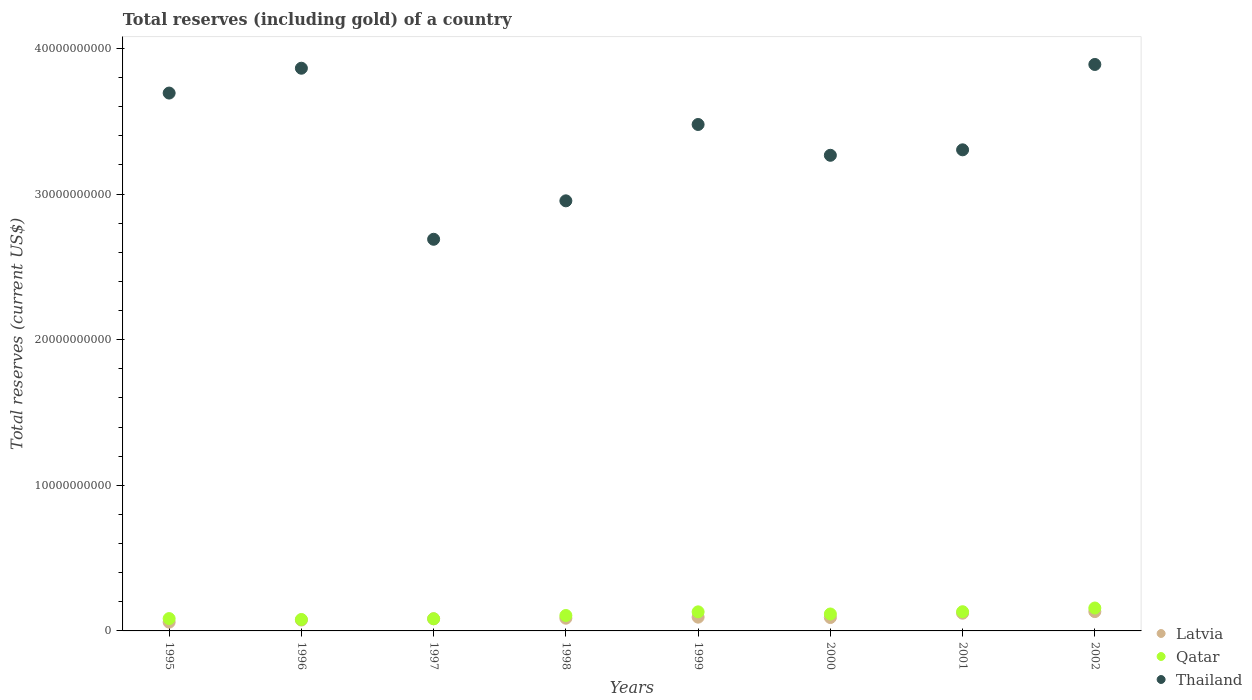How many different coloured dotlines are there?
Your answer should be very brief. 3. What is the total reserves (including gold) in Qatar in 2001?
Ensure brevity in your answer.  1.32e+09. Across all years, what is the maximum total reserves (including gold) in Qatar?
Offer a terse response. 1.57e+09. Across all years, what is the minimum total reserves (including gold) in Latvia?
Offer a terse response. 6.02e+08. In which year was the total reserves (including gold) in Latvia minimum?
Offer a terse response. 1995. What is the total total reserves (including gold) in Latvia in the graph?
Keep it short and to the point. 7.46e+09. What is the difference between the total reserves (including gold) in Latvia in 1999 and that in 2000?
Offer a terse response. 2.52e+07. What is the difference between the total reserves (including gold) in Qatar in 1997 and the total reserves (including gold) in Thailand in 1995?
Your answer should be very brief. -3.61e+1. What is the average total reserves (including gold) in Latvia per year?
Offer a very short reply. 9.33e+08. In the year 1996, what is the difference between the total reserves (including gold) in Thailand and total reserves (including gold) in Latvia?
Offer a very short reply. 3.79e+1. In how many years, is the total reserves (including gold) in Thailand greater than 14000000000 US$?
Your answer should be compact. 8. What is the ratio of the total reserves (including gold) in Qatar in 1999 to that in 2001?
Your answer should be compact. 0.99. What is the difference between the highest and the second highest total reserves (including gold) in Latvia?
Ensure brevity in your answer.  1.09e+08. What is the difference between the highest and the lowest total reserves (including gold) in Latvia?
Make the answer very short. 7.25e+08. In how many years, is the total reserves (including gold) in Latvia greater than the average total reserves (including gold) in Latvia taken over all years?
Your answer should be very brief. 3. Does the total reserves (including gold) in Thailand monotonically increase over the years?
Your answer should be compact. No. Is the total reserves (including gold) in Thailand strictly less than the total reserves (including gold) in Qatar over the years?
Your answer should be compact. No. How many dotlines are there?
Keep it short and to the point. 3. Are the values on the major ticks of Y-axis written in scientific E-notation?
Ensure brevity in your answer.  No. Does the graph contain any zero values?
Your answer should be very brief. No. Does the graph contain grids?
Your answer should be very brief. No. Where does the legend appear in the graph?
Provide a succinct answer. Bottom right. How many legend labels are there?
Your response must be concise. 3. What is the title of the graph?
Ensure brevity in your answer.  Total reserves (including gold) of a country. Does "Maldives" appear as one of the legend labels in the graph?
Offer a very short reply. No. What is the label or title of the X-axis?
Keep it short and to the point. Years. What is the label or title of the Y-axis?
Keep it short and to the point. Total reserves (current US$). What is the Total reserves (current US$) in Latvia in 1995?
Give a very brief answer. 6.02e+08. What is the Total reserves (current US$) of Qatar in 1995?
Provide a succinct answer. 8.48e+08. What is the Total reserves (current US$) of Thailand in 1995?
Provide a succinct answer. 3.69e+1. What is the Total reserves (current US$) in Latvia in 1996?
Ensure brevity in your answer.  7.46e+08. What is the Total reserves (current US$) of Qatar in 1996?
Your response must be concise. 7.85e+08. What is the Total reserves (current US$) in Thailand in 1996?
Your response must be concise. 3.86e+1. What is the Total reserves (current US$) of Latvia in 1997?
Offer a terse response. 8.32e+08. What is the Total reserves (current US$) of Qatar in 1997?
Provide a succinct answer. 8.36e+08. What is the Total reserves (current US$) of Thailand in 1997?
Make the answer very short. 2.69e+1. What is the Total reserves (current US$) in Latvia in 1998?
Provide a succinct answer. 8.73e+08. What is the Total reserves (current US$) of Qatar in 1998?
Provide a succinct answer. 1.06e+09. What is the Total reserves (current US$) of Thailand in 1998?
Your answer should be very brief. 2.95e+1. What is the Total reserves (current US$) of Latvia in 1999?
Keep it short and to the point. 9.44e+08. What is the Total reserves (current US$) of Qatar in 1999?
Your response must be concise. 1.31e+09. What is the Total reserves (current US$) in Thailand in 1999?
Give a very brief answer. 3.48e+1. What is the Total reserves (current US$) in Latvia in 2000?
Make the answer very short. 9.19e+08. What is the Total reserves (current US$) of Qatar in 2000?
Ensure brevity in your answer.  1.16e+09. What is the Total reserves (current US$) in Thailand in 2000?
Provide a succinct answer. 3.27e+1. What is the Total reserves (current US$) of Latvia in 2001?
Offer a terse response. 1.22e+09. What is the Total reserves (current US$) in Qatar in 2001?
Give a very brief answer. 1.32e+09. What is the Total reserves (current US$) in Thailand in 2001?
Your response must be concise. 3.30e+1. What is the Total reserves (current US$) of Latvia in 2002?
Provide a succinct answer. 1.33e+09. What is the Total reserves (current US$) in Qatar in 2002?
Provide a succinct answer. 1.57e+09. What is the Total reserves (current US$) of Thailand in 2002?
Provide a short and direct response. 3.89e+1. Across all years, what is the maximum Total reserves (current US$) in Latvia?
Keep it short and to the point. 1.33e+09. Across all years, what is the maximum Total reserves (current US$) of Qatar?
Keep it short and to the point. 1.57e+09. Across all years, what is the maximum Total reserves (current US$) of Thailand?
Your answer should be compact. 3.89e+1. Across all years, what is the minimum Total reserves (current US$) of Latvia?
Keep it short and to the point. 6.02e+08. Across all years, what is the minimum Total reserves (current US$) in Qatar?
Your answer should be compact. 7.85e+08. Across all years, what is the minimum Total reserves (current US$) of Thailand?
Provide a succinct answer. 2.69e+1. What is the total Total reserves (current US$) of Latvia in the graph?
Make the answer very short. 7.46e+09. What is the total Total reserves (current US$) in Qatar in the graph?
Provide a succinct answer. 8.89e+09. What is the total Total reserves (current US$) of Thailand in the graph?
Provide a short and direct response. 2.71e+11. What is the difference between the Total reserves (current US$) of Latvia in 1995 and that in 1996?
Offer a very short reply. -1.44e+08. What is the difference between the Total reserves (current US$) in Qatar in 1995 and that in 1996?
Provide a short and direct response. 6.23e+07. What is the difference between the Total reserves (current US$) in Thailand in 1995 and that in 1996?
Ensure brevity in your answer.  -1.71e+09. What is the difference between the Total reserves (current US$) of Latvia in 1995 and that in 1997?
Provide a succinct answer. -2.30e+08. What is the difference between the Total reserves (current US$) of Qatar in 1995 and that in 1997?
Offer a terse response. 1.13e+07. What is the difference between the Total reserves (current US$) in Thailand in 1995 and that in 1997?
Your response must be concise. 1.00e+1. What is the difference between the Total reserves (current US$) in Latvia in 1995 and that in 1998?
Make the answer very short. -2.71e+08. What is the difference between the Total reserves (current US$) in Qatar in 1995 and that in 1998?
Provide a succinct answer. -2.11e+08. What is the difference between the Total reserves (current US$) in Thailand in 1995 and that in 1998?
Offer a terse response. 7.40e+09. What is the difference between the Total reserves (current US$) in Latvia in 1995 and that in 1999?
Your answer should be very brief. -3.42e+08. What is the difference between the Total reserves (current US$) of Qatar in 1995 and that in 1999?
Your response must be concise. -4.62e+08. What is the difference between the Total reserves (current US$) of Thailand in 1995 and that in 1999?
Make the answer very short. 2.16e+09. What is the difference between the Total reserves (current US$) of Latvia in 1995 and that in 2000?
Your response must be concise. -3.17e+08. What is the difference between the Total reserves (current US$) of Qatar in 1995 and that in 2000?
Your answer should be very brief. -3.16e+08. What is the difference between the Total reserves (current US$) in Thailand in 1995 and that in 2000?
Offer a very short reply. 4.27e+09. What is the difference between the Total reserves (current US$) in Latvia in 1995 and that in 2001?
Your response must be concise. -6.15e+08. What is the difference between the Total reserves (current US$) in Qatar in 1995 and that in 2001?
Your response must be concise. -4.70e+08. What is the difference between the Total reserves (current US$) of Thailand in 1995 and that in 2001?
Provide a short and direct response. 3.90e+09. What is the difference between the Total reserves (current US$) of Latvia in 1995 and that in 2002?
Make the answer very short. -7.25e+08. What is the difference between the Total reserves (current US$) of Qatar in 1995 and that in 2002?
Provide a short and direct response. -7.26e+08. What is the difference between the Total reserves (current US$) in Thailand in 1995 and that in 2002?
Keep it short and to the point. -1.96e+09. What is the difference between the Total reserves (current US$) in Latvia in 1996 and that in 1997?
Your answer should be compact. -8.64e+07. What is the difference between the Total reserves (current US$) of Qatar in 1996 and that in 1997?
Your answer should be compact. -5.11e+07. What is the difference between the Total reserves (current US$) of Thailand in 1996 and that in 1997?
Keep it short and to the point. 1.17e+1. What is the difference between the Total reserves (current US$) in Latvia in 1996 and that in 1998?
Give a very brief answer. -1.27e+08. What is the difference between the Total reserves (current US$) of Qatar in 1996 and that in 1998?
Provide a succinct answer. -2.74e+08. What is the difference between the Total reserves (current US$) in Thailand in 1996 and that in 1998?
Offer a terse response. 9.11e+09. What is the difference between the Total reserves (current US$) of Latvia in 1996 and that in 1999?
Provide a short and direct response. -1.98e+08. What is the difference between the Total reserves (current US$) in Qatar in 1996 and that in 1999?
Your answer should be compact. -5.24e+08. What is the difference between the Total reserves (current US$) of Thailand in 1996 and that in 1999?
Offer a very short reply. 3.86e+09. What is the difference between the Total reserves (current US$) in Latvia in 1996 and that in 2000?
Your answer should be very brief. -1.73e+08. What is the difference between the Total reserves (current US$) of Qatar in 1996 and that in 2000?
Keep it short and to the point. -3.78e+08. What is the difference between the Total reserves (current US$) of Thailand in 1996 and that in 2000?
Offer a terse response. 5.98e+09. What is the difference between the Total reserves (current US$) in Latvia in 1996 and that in 2001?
Ensure brevity in your answer.  -4.71e+08. What is the difference between the Total reserves (current US$) in Qatar in 1996 and that in 2001?
Ensure brevity in your answer.  -5.33e+08. What is the difference between the Total reserves (current US$) of Thailand in 1996 and that in 2001?
Your answer should be very brief. 5.60e+09. What is the difference between the Total reserves (current US$) in Latvia in 1996 and that in 2002?
Ensure brevity in your answer.  -5.81e+08. What is the difference between the Total reserves (current US$) of Qatar in 1996 and that in 2002?
Make the answer very short. -7.88e+08. What is the difference between the Total reserves (current US$) in Thailand in 1996 and that in 2002?
Give a very brief answer. -2.59e+08. What is the difference between the Total reserves (current US$) in Latvia in 1997 and that in 1998?
Offer a terse response. -4.05e+07. What is the difference between the Total reserves (current US$) of Qatar in 1997 and that in 1998?
Your response must be concise. -2.23e+08. What is the difference between the Total reserves (current US$) of Thailand in 1997 and that in 1998?
Your answer should be compact. -2.64e+09. What is the difference between the Total reserves (current US$) in Latvia in 1997 and that in 1999?
Offer a very short reply. -1.12e+08. What is the difference between the Total reserves (current US$) of Qatar in 1997 and that in 1999?
Keep it short and to the point. -4.73e+08. What is the difference between the Total reserves (current US$) in Thailand in 1997 and that in 1999?
Offer a terse response. -7.88e+09. What is the difference between the Total reserves (current US$) in Latvia in 1997 and that in 2000?
Offer a terse response. -8.67e+07. What is the difference between the Total reserves (current US$) in Qatar in 1997 and that in 2000?
Provide a short and direct response. -3.27e+08. What is the difference between the Total reserves (current US$) of Thailand in 1997 and that in 2000?
Keep it short and to the point. -5.77e+09. What is the difference between the Total reserves (current US$) of Latvia in 1997 and that in 2001?
Make the answer very short. -3.85e+08. What is the difference between the Total reserves (current US$) in Qatar in 1997 and that in 2001?
Make the answer very short. -4.82e+08. What is the difference between the Total reserves (current US$) of Thailand in 1997 and that in 2001?
Offer a very short reply. -6.14e+09. What is the difference between the Total reserves (current US$) of Latvia in 1997 and that in 2002?
Your answer should be very brief. -4.94e+08. What is the difference between the Total reserves (current US$) in Qatar in 1997 and that in 2002?
Keep it short and to the point. -7.37e+08. What is the difference between the Total reserves (current US$) of Thailand in 1997 and that in 2002?
Offer a terse response. -1.20e+1. What is the difference between the Total reserves (current US$) of Latvia in 1998 and that in 1999?
Give a very brief answer. -7.14e+07. What is the difference between the Total reserves (current US$) in Qatar in 1998 and that in 1999?
Your answer should be compact. -2.51e+08. What is the difference between the Total reserves (current US$) in Thailand in 1998 and that in 1999?
Your answer should be compact. -5.24e+09. What is the difference between the Total reserves (current US$) of Latvia in 1998 and that in 2000?
Ensure brevity in your answer.  -4.62e+07. What is the difference between the Total reserves (current US$) of Qatar in 1998 and that in 2000?
Keep it short and to the point. -1.04e+08. What is the difference between the Total reserves (current US$) of Thailand in 1998 and that in 2000?
Make the answer very short. -3.13e+09. What is the difference between the Total reserves (current US$) in Latvia in 1998 and that in 2001?
Your response must be concise. -3.45e+08. What is the difference between the Total reserves (current US$) in Qatar in 1998 and that in 2001?
Keep it short and to the point. -2.59e+08. What is the difference between the Total reserves (current US$) of Thailand in 1998 and that in 2001?
Ensure brevity in your answer.  -3.50e+09. What is the difference between the Total reserves (current US$) of Latvia in 1998 and that in 2002?
Make the answer very short. -4.54e+08. What is the difference between the Total reserves (current US$) of Qatar in 1998 and that in 2002?
Provide a short and direct response. -5.14e+08. What is the difference between the Total reserves (current US$) of Thailand in 1998 and that in 2002?
Your answer should be compact. -9.37e+09. What is the difference between the Total reserves (current US$) in Latvia in 1999 and that in 2000?
Make the answer very short. 2.52e+07. What is the difference between the Total reserves (current US$) of Qatar in 1999 and that in 2000?
Give a very brief answer. 1.47e+08. What is the difference between the Total reserves (current US$) in Thailand in 1999 and that in 2000?
Offer a very short reply. 2.12e+09. What is the difference between the Total reserves (current US$) of Latvia in 1999 and that in 2001?
Give a very brief answer. -2.73e+08. What is the difference between the Total reserves (current US$) of Qatar in 1999 and that in 2001?
Your response must be concise. -8.23e+06. What is the difference between the Total reserves (current US$) in Thailand in 1999 and that in 2001?
Ensure brevity in your answer.  1.74e+09. What is the difference between the Total reserves (current US$) of Latvia in 1999 and that in 2002?
Make the answer very short. -3.82e+08. What is the difference between the Total reserves (current US$) of Qatar in 1999 and that in 2002?
Make the answer very short. -2.64e+08. What is the difference between the Total reserves (current US$) of Thailand in 1999 and that in 2002?
Ensure brevity in your answer.  -4.12e+09. What is the difference between the Total reserves (current US$) in Latvia in 2000 and that in 2001?
Offer a terse response. -2.98e+08. What is the difference between the Total reserves (current US$) of Qatar in 2000 and that in 2001?
Give a very brief answer. -1.55e+08. What is the difference between the Total reserves (current US$) in Thailand in 2000 and that in 2001?
Your answer should be very brief. -3.75e+08. What is the difference between the Total reserves (current US$) of Latvia in 2000 and that in 2002?
Your answer should be very brief. -4.07e+08. What is the difference between the Total reserves (current US$) of Qatar in 2000 and that in 2002?
Your answer should be compact. -4.10e+08. What is the difference between the Total reserves (current US$) in Thailand in 2000 and that in 2002?
Make the answer very short. -6.24e+09. What is the difference between the Total reserves (current US$) in Latvia in 2001 and that in 2002?
Your answer should be compact. -1.09e+08. What is the difference between the Total reserves (current US$) in Qatar in 2001 and that in 2002?
Keep it short and to the point. -2.55e+08. What is the difference between the Total reserves (current US$) in Thailand in 2001 and that in 2002?
Your response must be concise. -5.86e+09. What is the difference between the Total reserves (current US$) in Latvia in 1995 and the Total reserves (current US$) in Qatar in 1996?
Provide a succinct answer. -1.83e+08. What is the difference between the Total reserves (current US$) of Latvia in 1995 and the Total reserves (current US$) of Thailand in 1996?
Your answer should be very brief. -3.80e+1. What is the difference between the Total reserves (current US$) in Qatar in 1995 and the Total reserves (current US$) in Thailand in 1996?
Give a very brief answer. -3.78e+1. What is the difference between the Total reserves (current US$) in Latvia in 1995 and the Total reserves (current US$) in Qatar in 1997?
Provide a short and direct response. -2.34e+08. What is the difference between the Total reserves (current US$) in Latvia in 1995 and the Total reserves (current US$) in Thailand in 1997?
Make the answer very short. -2.63e+1. What is the difference between the Total reserves (current US$) of Qatar in 1995 and the Total reserves (current US$) of Thailand in 1997?
Offer a very short reply. -2.60e+1. What is the difference between the Total reserves (current US$) of Latvia in 1995 and the Total reserves (current US$) of Qatar in 1998?
Your response must be concise. -4.57e+08. What is the difference between the Total reserves (current US$) in Latvia in 1995 and the Total reserves (current US$) in Thailand in 1998?
Provide a short and direct response. -2.89e+1. What is the difference between the Total reserves (current US$) of Qatar in 1995 and the Total reserves (current US$) of Thailand in 1998?
Provide a short and direct response. -2.87e+1. What is the difference between the Total reserves (current US$) in Latvia in 1995 and the Total reserves (current US$) in Qatar in 1999?
Provide a succinct answer. -7.08e+08. What is the difference between the Total reserves (current US$) in Latvia in 1995 and the Total reserves (current US$) in Thailand in 1999?
Provide a succinct answer. -3.42e+1. What is the difference between the Total reserves (current US$) in Qatar in 1995 and the Total reserves (current US$) in Thailand in 1999?
Give a very brief answer. -3.39e+1. What is the difference between the Total reserves (current US$) of Latvia in 1995 and the Total reserves (current US$) of Qatar in 2000?
Offer a very short reply. -5.61e+08. What is the difference between the Total reserves (current US$) of Latvia in 1995 and the Total reserves (current US$) of Thailand in 2000?
Offer a terse response. -3.21e+1. What is the difference between the Total reserves (current US$) in Qatar in 1995 and the Total reserves (current US$) in Thailand in 2000?
Give a very brief answer. -3.18e+1. What is the difference between the Total reserves (current US$) of Latvia in 1995 and the Total reserves (current US$) of Qatar in 2001?
Provide a succinct answer. -7.16e+08. What is the difference between the Total reserves (current US$) of Latvia in 1995 and the Total reserves (current US$) of Thailand in 2001?
Your answer should be compact. -3.24e+1. What is the difference between the Total reserves (current US$) of Qatar in 1995 and the Total reserves (current US$) of Thailand in 2001?
Provide a short and direct response. -3.22e+1. What is the difference between the Total reserves (current US$) in Latvia in 1995 and the Total reserves (current US$) in Qatar in 2002?
Provide a succinct answer. -9.71e+08. What is the difference between the Total reserves (current US$) in Latvia in 1995 and the Total reserves (current US$) in Thailand in 2002?
Your response must be concise. -3.83e+1. What is the difference between the Total reserves (current US$) of Qatar in 1995 and the Total reserves (current US$) of Thailand in 2002?
Your response must be concise. -3.81e+1. What is the difference between the Total reserves (current US$) in Latvia in 1996 and the Total reserves (current US$) in Qatar in 1997?
Your answer should be very brief. -9.02e+07. What is the difference between the Total reserves (current US$) in Latvia in 1996 and the Total reserves (current US$) in Thailand in 1997?
Ensure brevity in your answer.  -2.62e+1. What is the difference between the Total reserves (current US$) in Qatar in 1996 and the Total reserves (current US$) in Thailand in 1997?
Your response must be concise. -2.61e+1. What is the difference between the Total reserves (current US$) in Latvia in 1996 and the Total reserves (current US$) in Qatar in 1998?
Your answer should be very brief. -3.13e+08. What is the difference between the Total reserves (current US$) of Latvia in 1996 and the Total reserves (current US$) of Thailand in 1998?
Provide a succinct answer. -2.88e+1. What is the difference between the Total reserves (current US$) in Qatar in 1996 and the Total reserves (current US$) in Thailand in 1998?
Keep it short and to the point. -2.88e+1. What is the difference between the Total reserves (current US$) in Latvia in 1996 and the Total reserves (current US$) in Qatar in 1999?
Ensure brevity in your answer.  -5.64e+08. What is the difference between the Total reserves (current US$) of Latvia in 1996 and the Total reserves (current US$) of Thailand in 1999?
Give a very brief answer. -3.40e+1. What is the difference between the Total reserves (current US$) in Qatar in 1996 and the Total reserves (current US$) in Thailand in 1999?
Offer a very short reply. -3.40e+1. What is the difference between the Total reserves (current US$) in Latvia in 1996 and the Total reserves (current US$) in Qatar in 2000?
Offer a terse response. -4.17e+08. What is the difference between the Total reserves (current US$) in Latvia in 1996 and the Total reserves (current US$) in Thailand in 2000?
Your answer should be very brief. -3.19e+1. What is the difference between the Total reserves (current US$) of Qatar in 1996 and the Total reserves (current US$) of Thailand in 2000?
Make the answer very short. -3.19e+1. What is the difference between the Total reserves (current US$) of Latvia in 1996 and the Total reserves (current US$) of Qatar in 2001?
Offer a terse response. -5.72e+08. What is the difference between the Total reserves (current US$) of Latvia in 1996 and the Total reserves (current US$) of Thailand in 2001?
Make the answer very short. -3.23e+1. What is the difference between the Total reserves (current US$) of Qatar in 1996 and the Total reserves (current US$) of Thailand in 2001?
Offer a very short reply. -3.23e+1. What is the difference between the Total reserves (current US$) in Latvia in 1996 and the Total reserves (current US$) in Qatar in 2002?
Provide a succinct answer. -8.27e+08. What is the difference between the Total reserves (current US$) of Latvia in 1996 and the Total reserves (current US$) of Thailand in 2002?
Provide a succinct answer. -3.82e+1. What is the difference between the Total reserves (current US$) in Qatar in 1996 and the Total reserves (current US$) in Thailand in 2002?
Your response must be concise. -3.81e+1. What is the difference between the Total reserves (current US$) of Latvia in 1997 and the Total reserves (current US$) of Qatar in 1998?
Provide a short and direct response. -2.26e+08. What is the difference between the Total reserves (current US$) of Latvia in 1997 and the Total reserves (current US$) of Thailand in 1998?
Offer a very short reply. -2.87e+1. What is the difference between the Total reserves (current US$) of Qatar in 1997 and the Total reserves (current US$) of Thailand in 1998?
Offer a very short reply. -2.87e+1. What is the difference between the Total reserves (current US$) of Latvia in 1997 and the Total reserves (current US$) of Qatar in 1999?
Provide a short and direct response. -4.77e+08. What is the difference between the Total reserves (current US$) in Latvia in 1997 and the Total reserves (current US$) in Thailand in 1999?
Ensure brevity in your answer.  -3.39e+1. What is the difference between the Total reserves (current US$) in Qatar in 1997 and the Total reserves (current US$) in Thailand in 1999?
Provide a succinct answer. -3.39e+1. What is the difference between the Total reserves (current US$) in Latvia in 1997 and the Total reserves (current US$) in Qatar in 2000?
Your response must be concise. -3.31e+08. What is the difference between the Total reserves (current US$) of Latvia in 1997 and the Total reserves (current US$) of Thailand in 2000?
Provide a succinct answer. -3.18e+1. What is the difference between the Total reserves (current US$) in Qatar in 1997 and the Total reserves (current US$) in Thailand in 2000?
Your answer should be very brief. -3.18e+1. What is the difference between the Total reserves (current US$) of Latvia in 1997 and the Total reserves (current US$) of Qatar in 2001?
Give a very brief answer. -4.85e+08. What is the difference between the Total reserves (current US$) of Latvia in 1997 and the Total reserves (current US$) of Thailand in 2001?
Provide a short and direct response. -3.22e+1. What is the difference between the Total reserves (current US$) of Qatar in 1997 and the Total reserves (current US$) of Thailand in 2001?
Your answer should be compact. -3.22e+1. What is the difference between the Total reserves (current US$) of Latvia in 1997 and the Total reserves (current US$) of Qatar in 2002?
Provide a short and direct response. -7.41e+08. What is the difference between the Total reserves (current US$) of Latvia in 1997 and the Total reserves (current US$) of Thailand in 2002?
Offer a terse response. -3.81e+1. What is the difference between the Total reserves (current US$) in Qatar in 1997 and the Total reserves (current US$) in Thailand in 2002?
Offer a very short reply. -3.81e+1. What is the difference between the Total reserves (current US$) of Latvia in 1998 and the Total reserves (current US$) of Qatar in 1999?
Give a very brief answer. -4.37e+08. What is the difference between the Total reserves (current US$) in Latvia in 1998 and the Total reserves (current US$) in Thailand in 1999?
Your response must be concise. -3.39e+1. What is the difference between the Total reserves (current US$) of Qatar in 1998 and the Total reserves (current US$) of Thailand in 1999?
Provide a succinct answer. -3.37e+1. What is the difference between the Total reserves (current US$) of Latvia in 1998 and the Total reserves (current US$) of Qatar in 2000?
Give a very brief answer. -2.90e+08. What is the difference between the Total reserves (current US$) in Latvia in 1998 and the Total reserves (current US$) in Thailand in 2000?
Provide a short and direct response. -3.18e+1. What is the difference between the Total reserves (current US$) of Qatar in 1998 and the Total reserves (current US$) of Thailand in 2000?
Offer a terse response. -3.16e+1. What is the difference between the Total reserves (current US$) in Latvia in 1998 and the Total reserves (current US$) in Qatar in 2001?
Your response must be concise. -4.45e+08. What is the difference between the Total reserves (current US$) of Latvia in 1998 and the Total reserves (current US$) of Thailand in 2001?
Offer a very short reply. -3.22e+1. What is the difference between the Total reserves (current US$) in Qatar in 1998 and the Total reserves (current US$) in Thailand in 2001?
Provide a short and direct response. -3.20e+1. What is the difference between the Total reserves (current US$) in Latvia in 1998 and the Total reserves (current US$) in Qatar in 2002?
Ensure brevity in your answer.  -7.00e+08. What is the difference between the Total reserves (current US$) of Latvia in 1998 and the Total reserves (current US$) of Thailand in 2002?
Provide a short and direct response. -3.80e+1. What is the difference between the Total reserves (current US$) in Qatar in 1998 and the Total reserves (current US$) in Thailand in 2002?
Your answer should be compact. -3.78e+1. What is the difference between the Total reserves (current US$) in Latvia in 1999 and the Total reserves (current US$) in Qatar in 2000?
Ensure brevity in your answer.  -2.19e+08. What is the difference between the Total reserves (current US$) in Latvia in 1999 and the Total reserves (current US$) in Thailand in 2000?
Offer a terse response. -3.17e+1. What is the difference between the Total reserves (current US$) of Qatar in 1999 and the Total reserves (current US$) of Thailand in 2000?
Offer a very short reply. -3.14e+1. What is the difference between the Total reserves (current US$) in Latvia in 1999 and the Total reserves (current US$) in Qatar in 2001?
Give a very brief answer. -3.74e+08. What is the difference between the Total reserves (current US$) in Latvia in 1999 and the Total reserves (current US$) in Thailand in 2001?
Offer a terse response. -3.21e+1. What is the difference between the Total reserves (current US$) of Qatar in 1999 and the Total reserves (current US$) of Thailand in 2001?
Provide a succinct answer. -3.17e+1. What is the difference between the Total reserves (current US$) of Latvia in 1999 and the Total reserves (current US$) of Qatar in 2002?
Make the answer very short. -6.29e+08. What is the difference between the Total reserves (current US$) in Latvia in 1999 and the Total reserves (current US$) in Thailand in 2002?
Make the answer very short. -3.80e+1. What is the difference between the Total reserves (current US$) in Qatar in 1999 and the Total reserves (current US$) in Thailand in 2002?
Make the answer very short. -3.76e+1. What is the difference between the Total reserves (current US$) of Latvia in 2000 and the Total reserves (current US$) of Qatar in 2001?
Give a very brief answer. -3.99e+08. What is the difference between the Total reserves (current US$) of Latvia in 2000 and the Total reserves (current US$) of Thailand in 2001?
Offer a terse response. -3.21e+1. What is the difference between the Total reserves (current US$) of Qatar in 2000 and the Total reserves (current US$) of Thailand in 2001?
Ensure brevity in your answer.  -3.19e+1. What is the difference between the Total reserves (current US$) in Latvia in 2000 and the Total reserves (current US$) in Qatar in 2002?
Your response must be concise. -6.54e+08. What is the difference between the Total reserves (current US$) in Latvia in 2000 and the Total reserves (current US$) in Thailand in 2002?
Make the answer very short. -3.80e+1. What is the difference between the Total reserves (current US$) in Qatar in 2000 and the Total reserves (current US$) in Thailand in 2002?
Give a very brief answer. -3.77e+1. What is the difference between the Total reserves (current US$) of Latvia in 2001 and the Total reserves (current US$) of Qatar in 2002?
Your answer should be compact. -3.56e+08. What is the difference between the Total reserves (current US$) of Latvia in 2001 and the Total reserves (current US$) of Thailand in 2002?
Your response must be concise. -3.77e+1. What is the difference between the Total reserves (current US$) in Qatar in 2001 and the Total reserves (current US$) in Thailand in 2002?
Offer a terse response. -3.76e+1. What is the average Total reserves (current US$) of Latvia per year?
Keep it short and to the point. 9.33e+08. What is the average Total reserves (current US$) in Qatar per year?
Your response must be concise. 1.11e+09. What is the average Total reserves (current US$) in Thailand per year?
Offer a terse response. 3.39e+1. In the year 1995, what is the difference between the Total reserves (current US$) in Latvia and Total reserves (current US$) in Qatar?
Keep it short and to the point. -2.46e+08. In the year 1995, what is the difference between the Total reserves (current US$) of Latvia and Total reserves (current US$) of Thailand?
Ensure brevity in your answer.  -3.63e+1. In the year 1995, what is the difference between the Total reserves (current US$) of Qatar and Total reserves (current US$) of Thailand?
Give a very brief answer. -3.61e+1. In the year 1996, what is the difference between the Total reserves (current US$) in Latvia and Total reserves (current US$) in Qatar?
Make the answer very short. -3.92e+07. In the year 1996, what is the difference between the Total reserves (current US$) of Latvia and Total reserves (current US$) of Thailand?
Provide a succinct answer. -3.79e+1. In the year 1996, what is the difference between the Total reserves (current US$) in Qatar and Total reserves (current US$) in Thailand?
Your response must be concise. -3.79e+1. In the year 1997, what is the difference between the Total reserves (current US$) in Latvia and Total reserves (current US$) in Qatar?
Give a very brief answer. -3.85e+06. In the year 1997, what is the difference between the Total reserves (current US$) in Latvia and Total reserves (current US$) in Thailand?
Provide a succinct answer. -2.61e+1. In the year 1997, what is the difference between the Total reserves (current US$) of Qatar and Total reserves (current US$) of Thailand?
Your answer should be compact. -2.61e+1. In the year 1998, what is the difference between the Total reserves (current US$) of Latvia and Total reserves (current US$) of Qatar?
Your response must be concise. -1.86e+08. In the year 1998, what is the difference between the Total reserves (current US$) in Latvia and Total reserves (current US$) in Thailand?
Your response must be concise. -2.87e+1. In the year 1998, what is the difference between the Total reserves (current US$) in Qatar and Total reserves (current US$) in Thailand?
Ensure brevity in your answer.  -2.85e+1. In the year 1999, what is the difference between the Total reserves (current US$) in Latvia and Total reserves (current US$) in Qatar?
Your answer should be very brief. -3.65e+08. In the year 1999, what is the difference between the Total reserves (current US$) in Latvia and Total reserves (current US$) in Thailand?
Provide a short and direct response. -3.38e+1. In the year 1999, what is the difference between the Total reserves (current US$) in Qatar and Total reserves (current US$) in Thailand?
Make the answer very short. -3.35e+1. In the year 2000, what is the difference between the Total reserves (current US$) in Latvia and Total reserves (current US$) in Qatar?
Your response must be concise. -2.44e+08. In the year 2000, what is the difference between the Total reserves (current US$) of Latvia and Total reserves (current US$) of Thailand?
Your response must be concise. -3.17e+1. In the year 2000, what is the difference between the Total reserves (current US$) in Qatar and Total reserves (current US$) in Thailand?
Provide a succinct answer. -3.15e+1. In the year 2001, what is the difference between the Total reserves (current US$) of Latvia and Total reserves (current US$) of Qatar?
Keep it short and to the point. -1.00e+08. In the year 2001, what is the difference between the Total reserves (current US$) of Latvia and Total reserves (current US$) of Thailand?
Provide a succinct answer. -3.18e+1. In the year 2001, what is the difference between the Total reserves (current US$) of Qatar and Total reserves (current US$) of Thailand?
Make the answer very short. -3.17e+1. In the year 2002, what is the difference between the Total reserves (current US$) in Latvia and Total reserves (current US$) in Qatar?
Provide a short and direct response. -2.47e+08. In the year 2002, what is the difference between the Total reserves (current US$) of Latvia and Total reserves (current US$) of Thailand?
Offer a terse response. -3.76e+1. In the year 2002, what is the difference between the Total reserves (current US$) in Qatar and Total reserves (current US$) in Thailand?
Keep it short and to the point. -3.73e+1. What is the ratio of the Total reserves (current US$) in Latvia in 1995 to that in 1996?
Your answer should be very brief. 0.81. What is the ratio of the Total reserves (current US$) in Qatar in 1995 to that in 1996?
Make the answer very short. 1.08. What is the ratio of the Total reserves (current US$) of Thailand in 1995 to that in 1996?
Your answer should be very brief. 0.96. What is the ratio of the Total reserves (current US$) in Latvia in 1995 to that in 1997?
Give a very brief answer. 0.72. What is the ratio of the Total reserves (current US$) in Qatar in 1995 to that in 1997?
Your answer should be compact. 1.01. What is the ratio of the Total reserves (current US$) in Thailand in 1995 to that in 1997?
Your answer should be very brief. 1.37. What is the ratio of the Total reserves (current US$) in Latvia in 1995 to that in 1998?
Your response must be concise. 0.69. What is the ratio of the Total reserves (current US$) in Qatar in 1995 to that in 1998?
Offer a terse response. 0.8. What is the ratio of the Total reserves (current US$) in Thailand in 1995 to that in 1998?
Provide a short and direct response. 1.25. What is the ratio of the Total reserves (current US$) of Latvia in 1995 to that in 1999?
Offer a terse response. 0.64. What is the ratio of the Total reserves (current US$) in Qatar in 1995 to that in 1999?
Offer a very short reply. 0.65. What is the ratio of the Total reserves (current US$) of Thailand in 1995 to that in 1999?
Provide a short and direct response. 1.06. What is the ratio of the Total reserves (current US$) in Latvia in 1995 to that in 2000?
Make the answer very short. 0.66. What is the ratio of the Total reserves (current US$) of Qatar in 1995 to that in 2000?
Provide a short and direct response. 0.73. What is the ratio of the Total reserves (current US$) of Thailand in 1995 to that in 2000?
Provide a short and direct response. 1.13. What is the ratio of the Total reserves (current US$) in Latvia in 1995 to that in 2001?
Provide a short and direct response. 0.49. What is the ratio of the Total reserves (current US$) of Qatar in 1995 to that in 2001?
Provide a succinct answer. 0.64. What is the ratio of the Total reserves (current US$) of Thailand in 1995 to that in 2001?
Ensure brevity in your answer.  1.12. What is the ratio of the Total reserves (current US$) in Latvia in 1995 to that in 2002?
Your answer should be compact. 0.45. What is the ratio of the Total reserves (current US$) of Qatar in 1995 to that in 2002?
Give a very brief answer. 0.54. What is the ratio of the Total reserves (current US$) in Thailand in 1995 to that in 2002?
Give a very brief answer. 0.95. What is the ratio of the Total reserves (current US$) of Latvia in 1996 to that in 1997?
Keep it short and to the point. 0.9. What is the ratio of the Total reserves (current US$) in Qatar in 1996 to that in 1997?
Ensure brevity in your answer.  0.94. What is the ratio of the Total reserves (current US$) in Thailand in 1996 to that in 1997?
Offer a very short reply. 1.44. What is the ratio of the Total reserves (current US$) of Latvia in 1996 to that in 1998?
Ensure brevity in your answer.  0.85. What is the ratio of the Total reserves (current US$) in Qatar in 1996 to that in 1998?
Offer a very short reply. 0.74. What is the ratio of the Total reserves (current US$) of Thailand in 1996 to that in 1998?
Your answer should be compact. 1.31. What is the ratio of the Total reserves (current US$) of Latvia in 1996 to that in 1999?
Offer a terse response. 0.79. What is the ratio of the Total reserves (current US$) in Qatar in 1996 to that in 1999?
Your response must be concise. 0.6. What is the ratio of the Total reserves (current US$) in Thailand in 1996 to that in 1999?
Give a very brief answer. 1.11. What is the ratio of the Total reserves (current US$) in Latvia in 1996 to that in 2000?
Make the answer very short. 0.81. What is the ratio of the Total reserves (current US$) in Qatar in 1996 to that in 2000?
Your response must be concise. 0.68. What is the ratio of the Total reserves (current US$) of Thailand in 1996 to that in 2000?
Your answer should be very brief. 1.18. What is the ratio of the Total reserves (current US$) of Latvia in 1996 to that in 2001?
Ensure brevity in your answer.  0.61. What is the ratio of the Total reserves (current US$) of Qatar in 1996 to that in 2001?
Offer a terse response. 0.6. What is the ratio of the Total reserves (current US$) of Thailand in 1996 to that in 2001?
Provide a succinct answer. 1.17. What is the ratio of the Total reserves (current US$) of Latvia in 1996 to that in 2002?
Give a very brief answer. 0.56. What is the ratio of the Total reserves (current US$) of Qatar in 1996 to that in 2002?
Make the answer very short. 0.5. What is the ratio of the Total reserves (current US$) of Latvia in 1997 to that in 1998?
Provide a succinct answer. 0.95. What is the ratio of the Total reserves (current US$) in Qatar in 1997 to that in 1998?
Provide a succinct answer. 0.79. What is the ratio of the Total reserves (current US$) of Thailand in 1997 to that in 1998?
Make the answer very short. 0.91. What is the ratio of the Total reserves (current US$) of Latvia in 1997 to that in 1999?
Give a very brief answer. 0.88. What is the ratio of the Total reserves (current US$) in Qatar in 1997 to that in 1999?
Offer a terse response. 0.64. What is the ratio of the Total reserves (current US$) in Thailand in 1997 to that in 1999?
Keep it short and to the point. 0.77. What is the ratio of the Total reserves (current US$) in Latvia in 1997 to that in 2000?
Provide a succinct answer. 0.91. What is the ratio of the Total reserves (current US$) in Qatar in 1997 to that in 2000?
Ensure brevity in your answer.  0.72. What is the ratio of the Total reserves (current US$) of Thailand in 1997 to that in 2000?
Offer a terse response. 0.82. What is the ratio of the Total reserves (current US$) of Latvia in 1997 to that in 2001?
Offer a very short reply. 0.68. What is the ratio of the Total reserves (current US$) in Qatar in 1997 to that in 2001?
Your response must be concise. 0.63. What is the ratio of the Total reserves (current US$) of Thailand in 1997 to that in 2001?
Give a very brief answer. 0.81. What is the ratio of the Total reserves (current US$) of Latvia in 1997 to that in 2002?
Make the answer very short. 0.63. What is the ratio of the Total reserves (current US$) of Qatar in 1997 to that in 2002?
Your answer should be compact. 0.53. What is the ratio of the Total reserves (current US$) in Thailand in 1997 to that in 2002?
Give a very brief answer. 0.69. What is the ratio of the Total reserves (current US$) in Latvia in 1998 to that in 1999?
Offer a very short reply. 0.92. What is the ratio of the Total reserves (current US$) of Qatar in 1998 to that in 1999?
Provide a succinct answer. 0.81. What is the ratio of the Total reserves (current US$) in Thailand in 1998 to that in 1999?
Provide a succinct answer. 0.85. What is the ratio of the Total reserves (current US$) of Latvia in 1998 to that in 2000?
Your answer should be compact. 0.95. What is the ratio of the Total reserves (current US$) of Qatar in 1998 to that in 2000?
Give a very brief answer. 0.91. What is the ratio of the Total reserves (current US$) in Thailand in 1998 to that in 2000?
Your answer should be very brief. 0.9. What is the ratio of the Total reserves (current US$) in Latvia in 1998 to that in 2001?
Provide a short and direct response. 0.72. What is the ratio of the Total reserves (current US$) of Qatar in 1998 to that in 2001?
Make the answer very short. 0.8. What is the ratio of the Total reserves (current US$) in Thailand in 1998 to that in 2001?
Provide a short and direct response. 0.89. What is the ratio of the Total reserves (current US$) of Latvia in 1998 to that in 2002?
Keep it short and to the point. 0.66. What is the ratio of the Total reserves (current US$) of Qatar in 1998 to that in 2002?
Provide a short and direct response. 0.67. What is the ratio of the Total reserves (current US$) in Thailand in 1998 to that in 2002?
Your answer should be very brief. 0.76. What is the ratio of the Total reserves (current US$) of Latvia in 1999 to that in 2000?
Ensure brevity in your answer.  1.03. What is the ratio of the Total reserves (current US$) of Qatar in 1999 to that in 2000?
Offer a very short reply. 1.13. What is the ratio of the Total reserves (current US$) of Thailand in 1999 to that in 2000?
Give a very brief answer. 1.06. What is the ratio of the Total reserves (current US$) of Latvia in 1999 to that in 2001?
Offer a very short reply. 0.78. What is the ratio of the Total reserves (current US$) in Qatar in 1999 to that in 2001?
Keep it short and to the point. 0.99. What is the ratio of the Total reserves (current US$) of Thailand in 1999 to that in 2001?
Provide a short and direct response. 1.05. What is the ratio of the Total reserves (current US$) of Latvia in 1999 to that in 2002?
Keep it short and to the point. 0.71. What is the ratio of the Total reserves (current US$) in Qatar in 1999 to that in 2002?
Your answer should be compact. 0.83. What is the ratio of the Total reserves (current US$) in Thailand in 1999 to that in 2002?
Your answer should be compact. 0.89. What is the ratio of the Total reserves (current US$) of Latvia in 2000 to that in 2001?
Your answer should be compact. 0.76. What is the ratio of the Total reserves (current US$) of Qatar in 2000 to that in 2001?
Your answer should be very brief. 0.88. What is the ratio of the Total reserves (current US$) in Latvia in 2000 to that in 2002?
Offer a very short reply. 0.69. What is the ratio of the Total reserves (current US$) of Qatar in 2000 to that in 2002?
Ensure brevity in your answer.  0.74. What is the ratio of the Total reserves (current US$) in Thailand in 2000 to that in 2002?
Give a very brief answer. 0.84. What is the ratio of the Total reserves (current US$) of Latvia in 2001 to that in 2002?
Provide a short and direct response. 0.92. What is the ratio of the Total reserves (current US$) of Qatar in 2001 to that in 2002?
Provide a succinct answer. 0.84. What is the ratio of the Total reserves (current US$) of Thailand in 2001 to that in 2002?
Keep it short and to the point. 0.85. What is the difference between the highest and the second highest Total reserves (current US$) in Latvia?
Your answer should be very brief. 1.09e+08. What is the difference between the highest and the second highest Total reserves (current US$) in Qatar?
Give a very brief answer. 2.55e+08. What is the difference between the highest and the second highest Total reserves (current US$) of Thailand?
Give a very brief answer. 2.59e+08. What is the difference between the highest and the lowest Total reserves (current US$) in Latvia?
Provide a short and direct response. 7.25e+08. What is the difference between the highest and the lowest Total reserves (current US$) in Qatar?
Keep it short and to the point. 7.88e+08. What is the difference between the highest and the lowest Total reserves (current US$) of Thailand?
Give a very brief answer. 1.20e+1. 